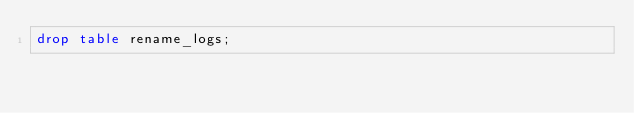Convert code to text. <code><loc_0><loc_0><loc_500><loc_500><_SQL_>drop table rename_logs;</code> 